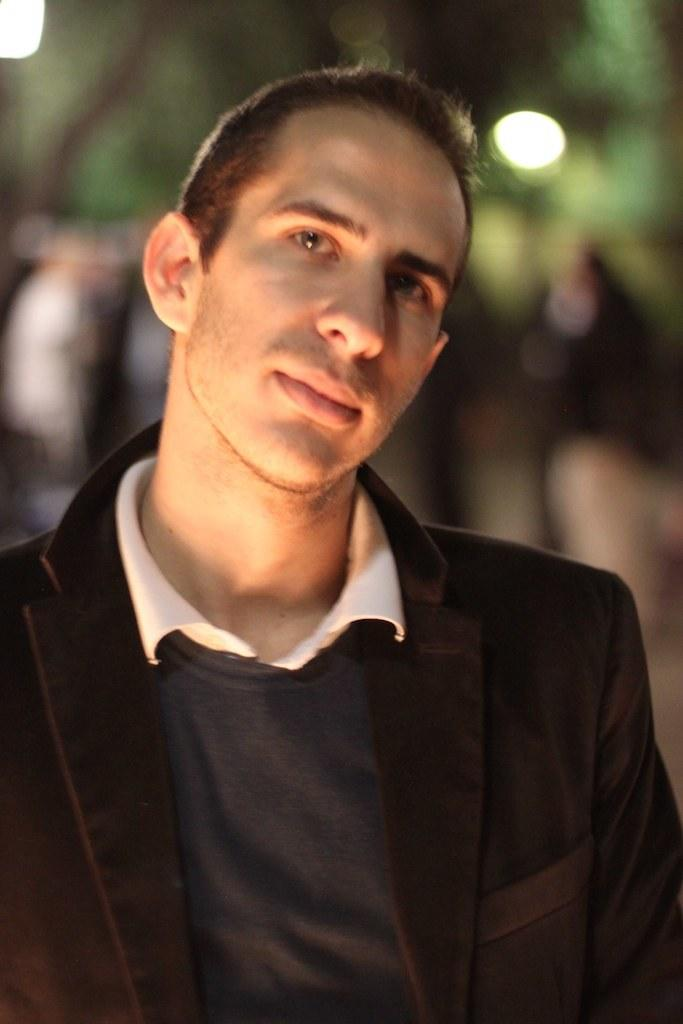Who is present in the image? There is a man in the image. What is the man wearing? The man is wearing a black jacket. What can be seen in the background of the image? There is a tree and a light in the background of the image. How is the background of the image depicted? The background of the image is blurred. What pets are mentioned in the caption of the image? There is no caption present in the image, and therefore no pets are mentioned. 